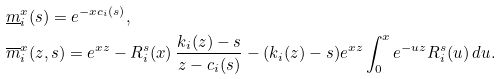<formula> <loc_0><loc_0><loc_500><loc_500>& \underline { m } _ { i } ^ { x } ( s ) = e ^ { - x c _ { i } ( s ) } , \\ & \overline { m } _ { i } ^ { x } ( z , s ) = e ^ { x z } - R _ { i } ^ { s } ( x ) \, \frac { k _ { i } ( z ) - s } { z - c _ { i } ( s ) } - ( k _ { i } ( z ) - s ) e ^ { x z } \int _ { 0 } ^ { x } e ^ { - u z } R _ { i } ^ { s } ( u ) \, d u .</formula> 